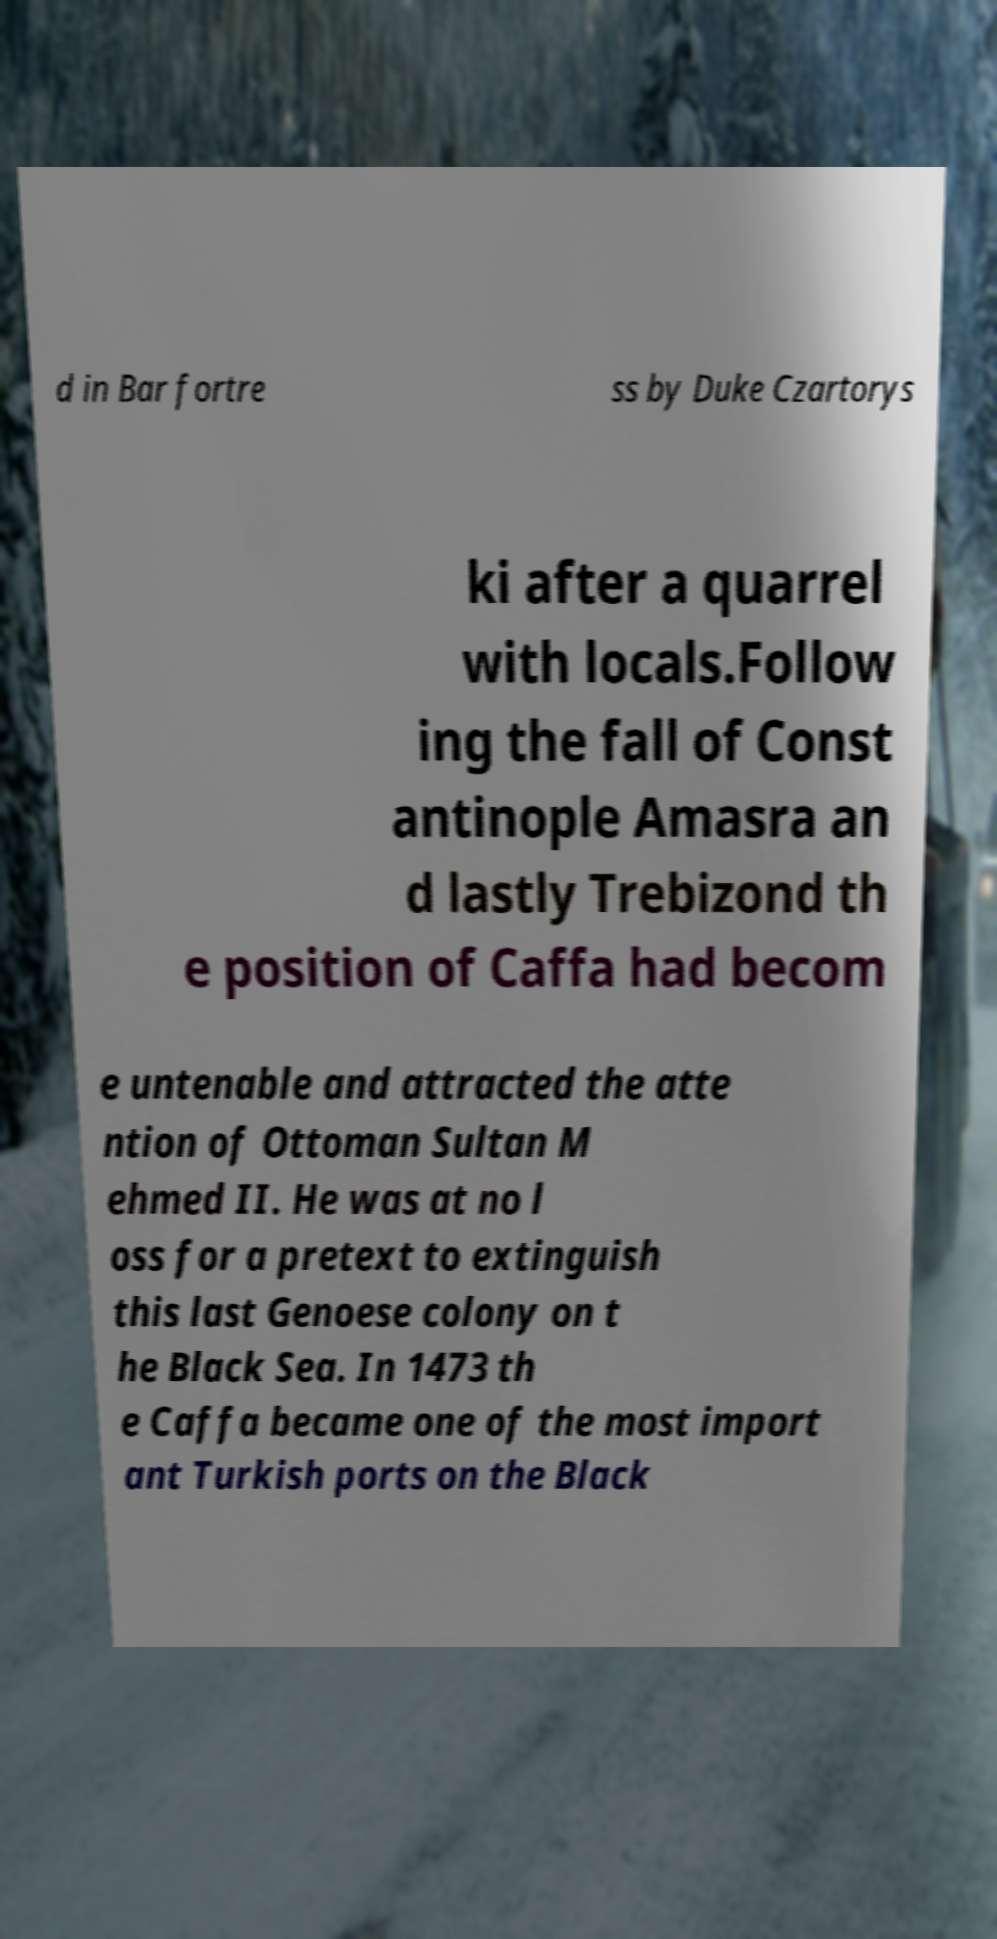Can you read and provide the text displayed in the image?This photo seems to have some interesting text. Can you extract and type it out for me? d in Bar fortre ss by Duke Czartorys ki after a quarrel with locals.Follow ing the fall of Const antinople Amasra an d lastly Trebizond th e position of Caffa had becom e untenable and attracted the atte ntion of Ottoman Sultan M ehmed II. He was at no l oss for a pretext to extinguish this last Genoese colony on t he Black Sea. In 1473 th e Caffa became one of the most import ant Turkish ports on the Black 